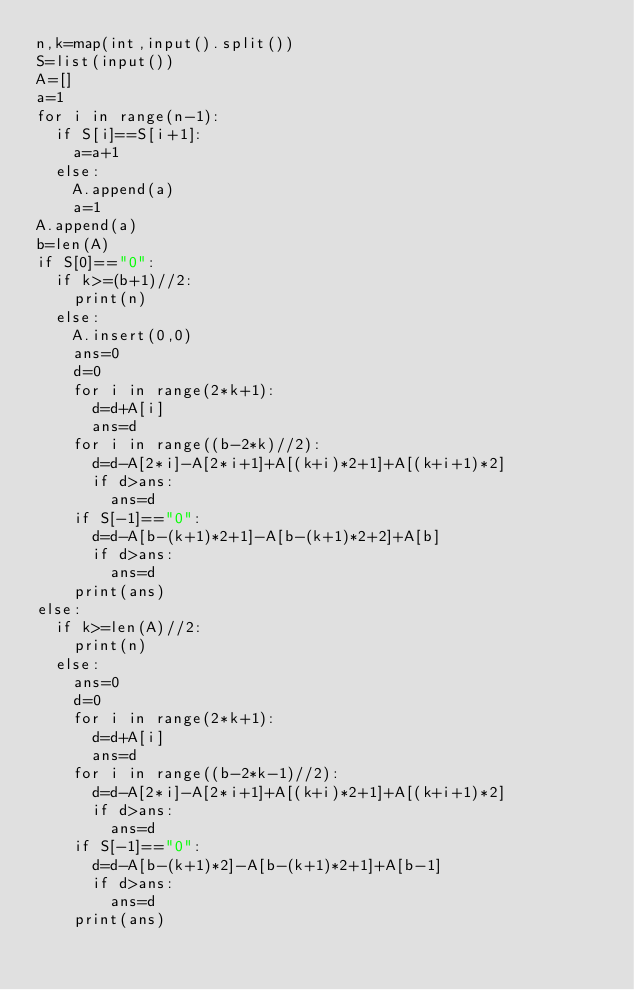Convert code to text. <code><loc_0><loc_0><loc_500><loc_500><_Python_>n,k=map(int,input().split())
S=list(input())
A=[]
a=1
for i in range(n-1):
  if S[i]==S[i+1]:
    a=a+1
  else:
    A.append(a)
    a=1
A.append(a)
b=len(A)
if S[0]=="0":
  if k>=(b+1)//2:
    print(n)
  else:
    A.insert(0,0)
    ans=0
    d=0
    for i in range(2*k+1):
      d=d+A[i]
      ans=d
    for i in range((b-2*k)//2):
      d=d-A[2*i]-A[2*i+1]+A[(k+i)*2+1]+A[(k+i+1)*2]
      if d>ans:
        ans=d
    if S[-1]=="0":
      d=d-A[b-(k+1)*2+1]-A[b-(k+1)*2+2]+A[b]
      if d>ans:
        ans=d
    print(ans)  
else:
  if k>=len(A)//2:
    print(n)
  else:
    ans=0
    d=0
    for i in range(2*k+1):
      d=d+A[i]
      ans=d
    for i in range((b-2*k-1)//2):
      d=d-A[2*i]-A[2*i+1]+A[(k+i)*2+1]+A[(k+i+1)*2]
      if d>ans:
        ans=d
    if S[-1]=="0":
      d=d-A[b-(k+1)*2]-A[b-(k+1)*2+1]+A[b-1]
      if d>ans:
        ans=d
    print(ans)</code> 